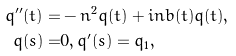Convert formula to latex. <formula><loc_0><loc_0><loc_500><loc_500>q ^ { \prime \prime } ( t ) = & - n ^ { 2 } q ( t ) + i n b ( t ) q ( t ) , \\ q ( s ) = & 0 , q ^ { \prime } ( s ) = q _ { 1 } ,</formula> 